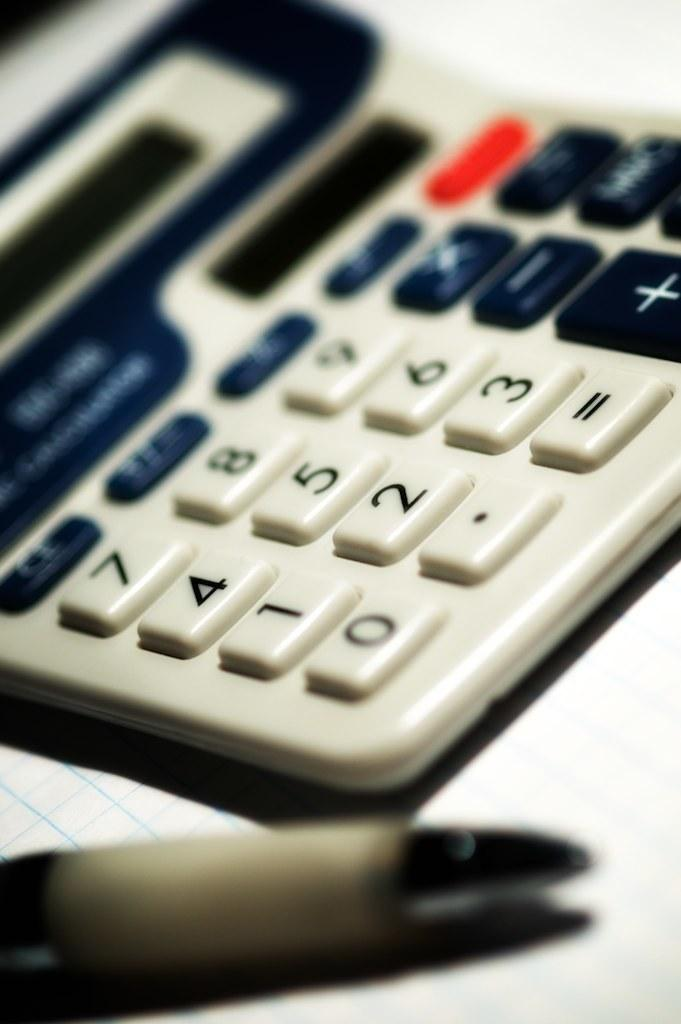<image>
Relay a brief, clear account of the picture shown. The four and two on a calculator are visible despite the depth of focus of the image. 